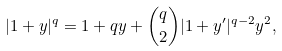<formula> <loc_0><loc_0><loc_500><loc_500>| 1 + y | ^ { q } = 1 + q y + \binom { q } { 2 } | 1 + y ^ { \prime } | ^ { q - 2 } y ^ { 2 } ,</formula> 